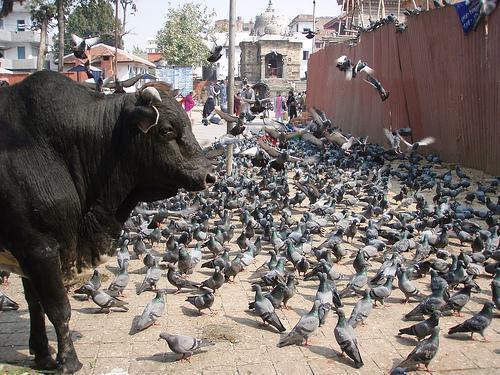How many bulls are there?
Give a very brief answer. 1. 